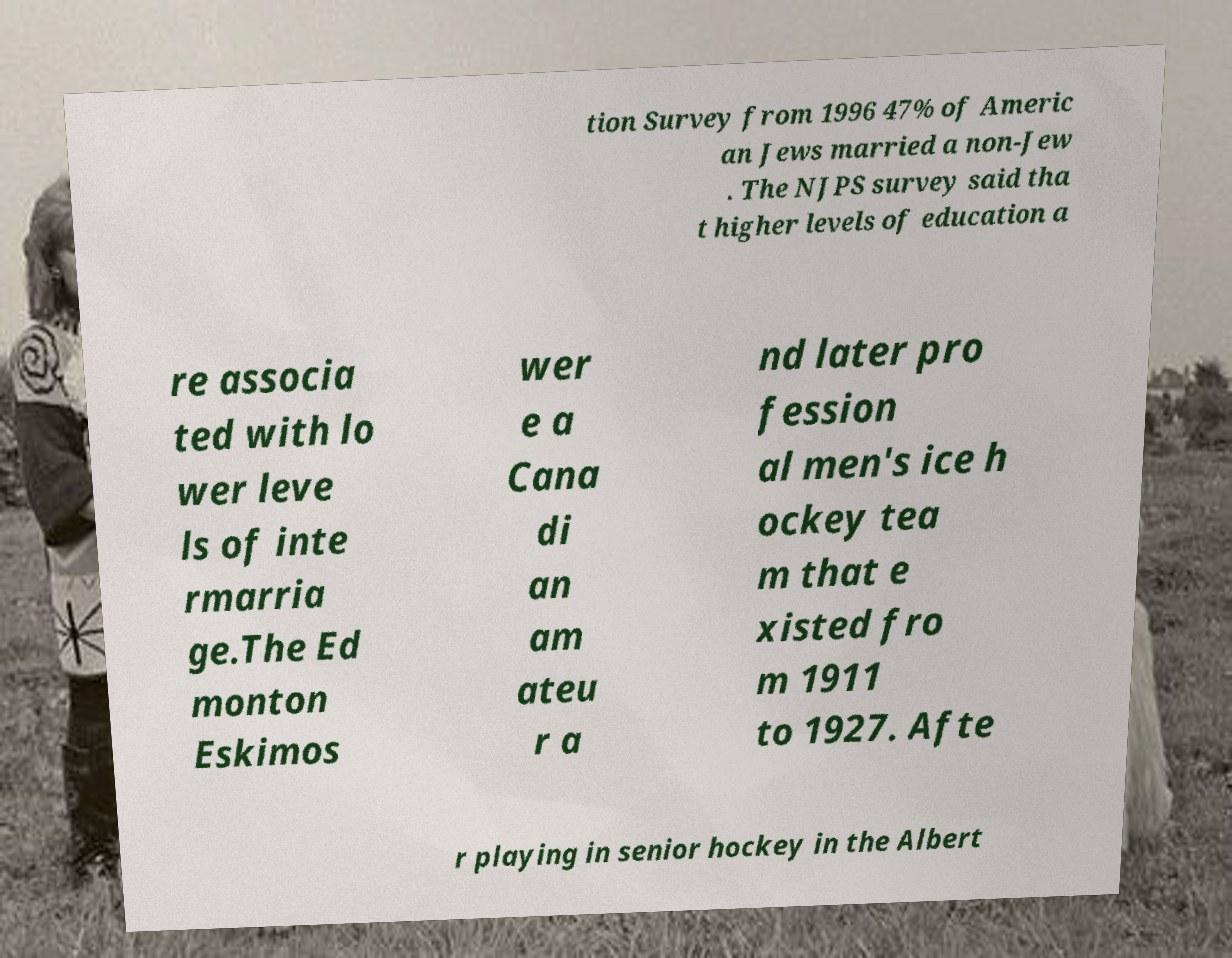What messages or text are displayed in this image? I need them in a readable, typed format. tion Survey from 1996 47% of Americ an Jews married a non-Jew . The NJPS survey said tha t higher levels of education a re associa ted with lo wer leve ls of inte rmarria ge.The Ed monton Eskimos wer e a Cana di an am ateu r a nd later pro fession al men's ice h ockey tea m that e xisted fro m 1911 to 1927. Afte r playing in senior hockey in the Albert 